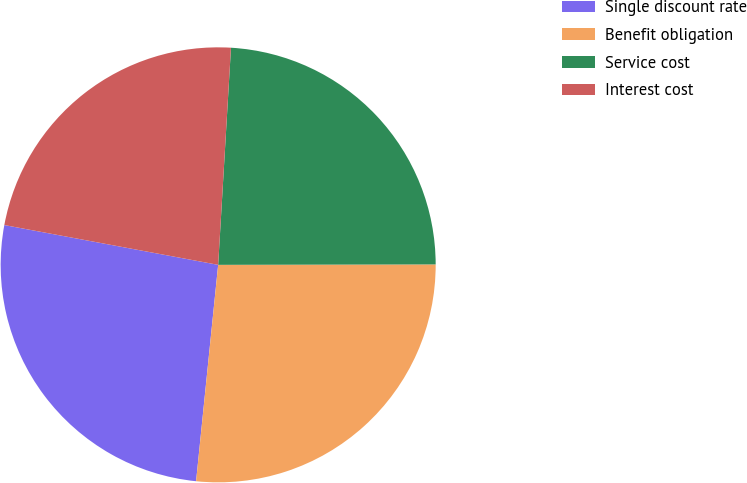Convert chart to OTSL. <chart><loc_0><loc_0><loc_500><loc_500><pie_chart><fcel>Single discount rate<fcel>Benefit obligation<fcel>Service cost<fcel>Interest cost<nl><fcel>26.31%<fcel>26.65%<fcel>24.03%<fcel>23.01%<nl></chart> 